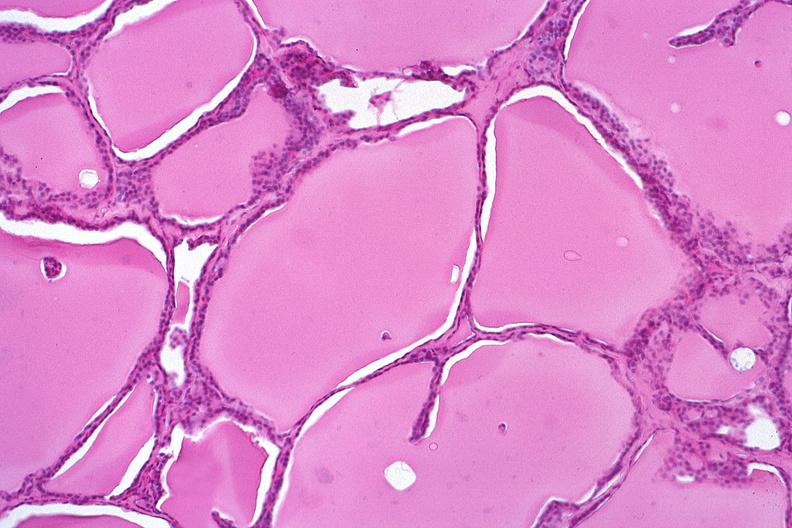what is present?
Answer the question using a single word or phrase. Endocrine 